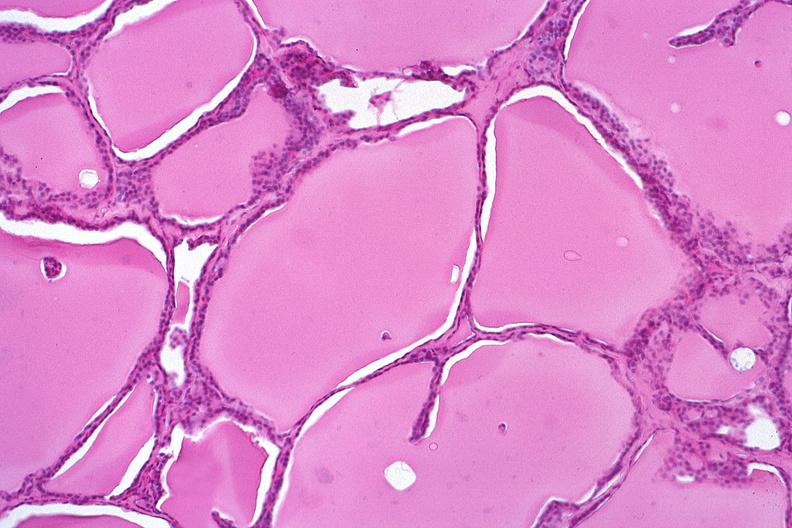what is present?
Answer the question using a single word or phrase. Endocrine 